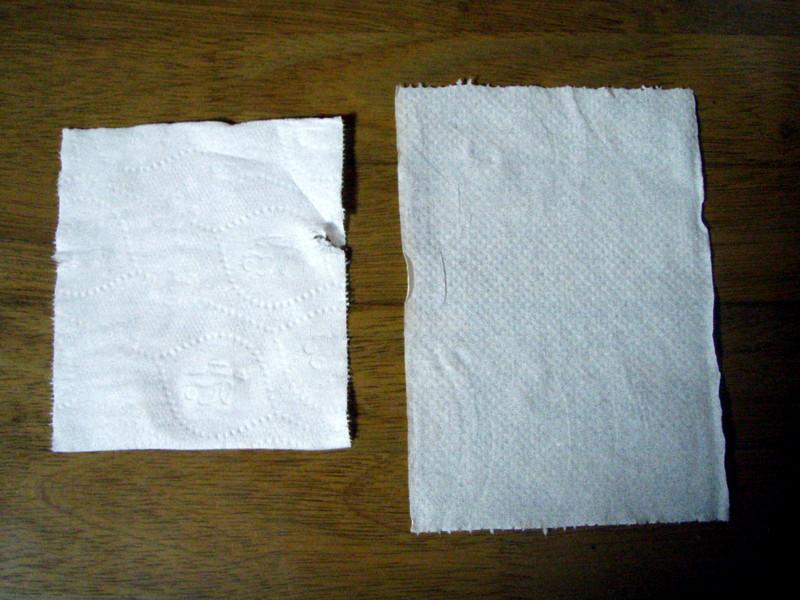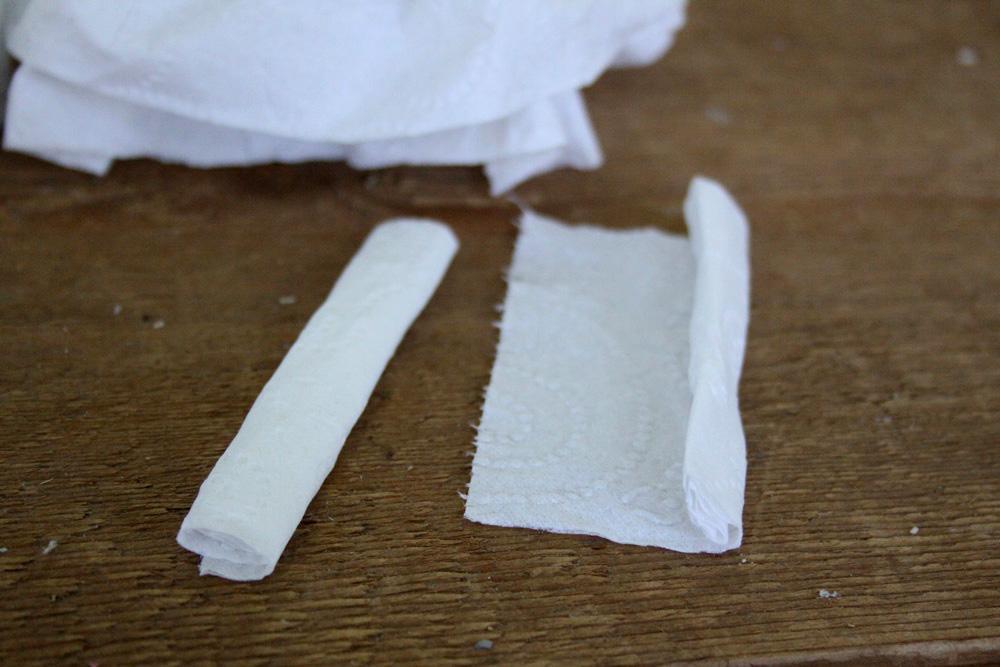The first image is the image on the left, the second image is the image on the right. Evaluate the accuracy of this statement regarding the images: "An image shows overlapping square white paper towels, each with the same embossed pattern.". Is it true? Answer yes or no. No. The first image is the image on the left, the second image is the image on the right. Examine the images to the left and right. Is the description "There are exactly five visible paper towels." accurate? Answer yes or no. No. 